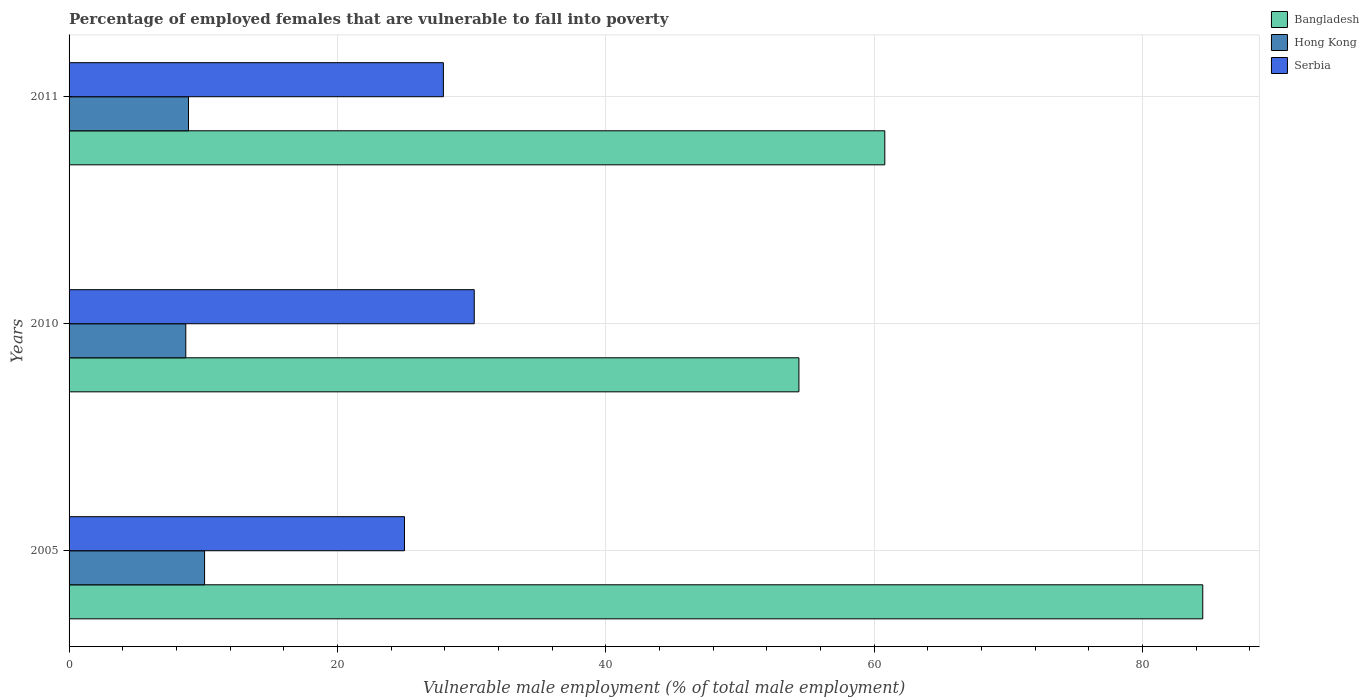How many groups of bars are there?
Ensure brevity in your answer.  3. Are the number of bars per tick equal to the number of legend labels?
Provide a short and direct response. Yes. Are the number of bars on each tick of the Y-axis equal?
Make the answer very short. Yes. How many bars are there on the 2nd tick from the bottom?
Your answer should be very brief. 3. What is the label of the 3rd group of bars from the top?
Your response must be concise. 2005. What is the percentage of employed females who are vulnerable to fall into poverty in Serbia in 2010?
Provide a succinct answer. 30.2. Across all years, what is the maximum percentage of employed females who are vulnerable to fall into poverty in Serbia?
Keep it short and to the point. 30.2. Across all years, what is the minimum percentage of employed females who are vulnerable to fall into poverty in Serbia?
Provide a succinct answer. 25. In which year was the percentage of employed females who are vulnerable to fall into poverty in Hong Kong minimum?
Your response must be concise. 2010. What is the total percentage of employed females who are vulnerable to fall into poverty in Bangladesh in the graph?
Your response must be concise. 199.7. What is the difference between the percentage of employed females who are vulnerable to fall into poverty in Bangladesh in 2005 and that in 2010?
Provide a succinct answer. 30.1. What is the difference between the percentage of employed females who are vulnerable to fall into poverty in Hong Kong in 2010 and the percentage of employed females who are vulnerable to fall into poverty in Serbia in 2005?
Give a very brief answer. -16.3. What is the average percentage of employed females who are vulnerable to fall into poverty in Serbia per year?
Keep it short and to the point. 27.7. In the year 2010, what is the difference between the percentage of employed females who are vulnerable to fall into poverty in Serbia and percentage of employed females who are vulnerable to fall into poverty in Bangladesh?
Give a very brief answer. -24.2. In how many years, is the percentage of employed females who are vulnerable to fall into poverty in Serbia greater than 24 %?
Give a very brief answer. 3. What is the ratio of the percentage of employed females who are vulnerable to fall into poverty in Serbia in 2005 to that in 2010?
Make the answer very short. 0.83. What is the difference between the highest and the second highest percentage of employed females who are vulnerable to fall into poverty in Bangladesh?
Your response must be concise. 23.7. What is the difference between the highest and the lowest percentage of employed females who are vulnerable to fall into poverty in Hong Kong?
Provide a short and direct response. 1.4. In how many years, is the percentage of employed females who are vulnerable to fall into poverty in Bangladesh greater than the average percentage of employed females who are vulnerable to fall into poverty in Bangladesh taken over all years?
Provide a short and direct response. 1. What does the 1st bar from the top in 2005 represents?
Provide a succinct answer. Serbia. What does the 2nd bar from the bottom in 2005 represents?
Give a very brief answer. Hong Kong. Is it the case that in every year, the sum of the percentage of employed females who are vulnerable to fall into poverty in Serbia and percentage of employed females who are vulnerable to fall into poverty in Hong Kong is greater than the percentage of employed females who are vulnerable to fall into poverty in Bangladesh?
Your answer should be compact. No. How many bars are there?
Your answer should be very brief. 9. What is the title of the graph?
Offer a terse response. Percentage of employed females that are vulnerable to fall into poverty. What is the label or title of the X-axis?
Your response must be concise. Vulnerable male employment (% of total male employment). What is the label or title of the Y-axis?
Your answer should be compact. Years. What is the Vulnerable male employment (% of total male employment) in Bangladesh in 2005?
Ensure brevity in your answer.  84.5. What is the Vulnerable male employment (% of total male employment) of Hong Kong in 2005?
Offer a terse response. 10.1. What is the Vulnerable male employment (% of total male employment) of Serbia in 2005?
Give a very brief answer. 25. What is the Vulnerable male employment (% of total male employment) in Bangladesh in 2010?
Your answer should be compact. 54.4. What is the Vulnerable male employment (% of total male employment) in Hong Kong in 2010?
Provide a short and direct response. 8.7. What is the Vulnerable male employment (% of total male employment) in Serbia in 2010?
Offer a very short reply. 30.2. What is the Vulnerable male employment (% of total male employment) of Bangladesh in 2011?
Ensure brevity in your answer.  60.8. What is the Vulnerable male employment (% of total male employment) in Hong Kong in 2011?
Keep it short and to the point. 8.9. What is the Vulnerable male employment (% of total male employment) in Serbia in 2011?
Your answer should be very brief. 27.9. Across all years, what is the maximum Vulnerable male employment (% of total male employment) in Bangladesh?
Ensure brevity in your answer.  84.5. Across all years, what is the maximum Vulnerable male employment (% of total male employment) of Hong Kong?
Make the answer very short. 10.1. Across all years, what is the maximum Vulnerable male employment (% of total male employment) in Serbia?
Provide a succinct answer. 30.2. Across all years, what is the minimum Vulnerable male employment (% of total male employment) of Bangladesh?
Ensure brevity in your answer.  54.4. Across all years, what is the minimum Vulnerable male employment (% of total male employment) in Hong Kong?
Provide a succinct answer. 8.7. What is the total Vulnerable male employment (% of total male employment) of Bangladesh in the graph?
Offer a terse response. 199.7. What is the total Vulnerable male employment (% of total male employment) of Hong Kong in the graph?
Provide a succinct answer. 27.7. What is the total Vulnerable male employment (% of total male employment) in Serbia in the graph?
Ensure brevity in your answer.  83.1. What is the difference between the Vulnerable male employment (% of total male employment) of Bangladesh in 2005 and that in 2010?
Offer a terse response. 30.1. What is the difference between the Vulnerable male employment (% of total male employment) of Bangladesh in 2005 and that in 2011?
Keep it short and to the point. 23.7. What is the difference between the Vulnerable male employment (% of total male employment) of Serbia in 2005 and that in 2011?
Ensure brevity in your answer.  -2.9. What is the difference between the Vulnerable male employment (% of total male employment) in Bangladesh in 2010 and that in 2011?
Keep it short and to the point. -6.4. What is the difference between the Vulnerable male employment (% of total male employment) in Bangladesh in 2005 and the Vulnerable male employment (% of total male employment) in Hong Kong in 2010?
Your response must be concise. 75.8. What is the difference between the Vulnerable male employment (% of total male employment) in Bangladesh in 2005 and the Vulnerable male employment (% of total male employment) in Serbia in 2010?
Your answer should be very brief. 54.3. What is the difference between the Vulnerable male employment (% of total male employment) of Hong Kong in 2005 and the Vulnerable male employment (% of total male employment) of Serbia in 2010?
Give a very brief answer. -20.1. What is the difference between the Vulnerable male employment (% of total male employment) in Bangladesh in 2005 and the Vulnerable male employment (% of total male employment) in Hong Kong in 2011?
Your response must be concise. 75.6. What is the difference between the Vulnerable male employment (% of total male employment) of Bangladesh in 2005 and the Vulnerable male employment (% of total male employment) of Serbia in 2011?
Make the answer very short. 56.6. What is the difference between the Vulnerable male employment (% of total male employment) in Hong Kong in 2005 and the Vulnerable male employment (% of total male employment) in Serbia in 2011?
Provide a short and direct response. -17.8. What is the difference between the Vulnerable male employment (% of total male employment) in Bangladesh in 2010 and the Vulnerable male employment (% of total male employment) in Hong Kong in 2011?
Ensure brevity in your answer.  45.5. What is the difference between the Vulnerable male employment (% of total male employment) of Bangladesh in 2010 and the Vulnerable male employment (% of total male employment) of Serbia in 2011?
Ensure brevity in your answer.  26.5. What is the difference between the Vulnerable male employment (% of total male employment) in Hong Kong in 2010 and the Vulnerable male employment (% of total male employment) in Serbia in 2011?
Keep it short and to the point. -19.2. What is the average Vulnerable male employment (% of total male employment) in Bangladesh per year?
Ensure brevity in your answer.  66.57. What is the average Vulnerable male employment (% of total male employment) of Hong Kong per year?
Make the answer very short. 9.23. What is the average Vulnerable male employment (% of total male employment) of Serbia per year?
Make the answer very short. 27.7. In the year 2005, what is the difference between the Vulnerable male employment (% of total male employment) in Bangladesh and Vulnerable male employment (% of total male employment) in Hong Kong?
Ensure brevity in your answer.  74.4. In the year 2005, what is the difference between the Vulnerable male employment (% of total male employment) in Bangladesh and Vulnerable male employment (% of total male employment) in Serbia?
Provide a short and direct response. 59.5. In the year 2005, what is the difference between the Vulnerable male employment (% of total male employment) of Hong Kong and Vulnerable male employment (% of total male employment) of Serbia?
Keep it short and to the point. -14.9. In the year 2010, what is the difference between the Vulnerable male employment (% of total male employment) of Bangladesh and Vulnerable male employment (% of total male employment) of Hong Kong?
Make the answer very short. 45.7. In the year 2010, what is the difference between the Vulnerable male employment (% of total male employment) of Bangladesh and Vulnerable male employment (% of total male employment) of Serbia?
Your answer should be compact. 24.2. In the year 2010, what is the difference between the Vulnerable male employment (% of total male employment) of Hong Kong and Vulnerable male employment (% of total male employment) of Serbia?
Offer a very short reply. -21.5. In the year 2011, what is the difference between the Vulnerable male employment (% of total male employment) of Bangladesh and Vulnerable male employment (% of total male employment) of Hong Kong?
Keep it short and to the point. 51.9. In the year 2011, what is the difference between the Vulnerable male employment (% of total male employment) of Bangladesh and Vulnerable male employment (% of total male employment) of Serbia?
Make the answer very short. 32.9. In the year 2011, what is the difference between the Vulnerable male employment (% of total male employment) in Hong Kong and Vulnerable male employment (% of total male employment) in Serbia?
Provide a short and direct response. -19. What is the ratio of the Vulnerable male employment (% of total male employment) of Bangladesh in 2005 to that in 2010?
Your answer should be compact. 1.55. What is the ratio of the Vulnerable male employment (% of total male employment) in Hong Kong in 2005 to that in 2010?
Provide a short and direct response. 1.16. What is the ratio of the Vulnerable male employment (% of total male employment) of Serbia in 2005 to that in 2010?
Provide a succinct answer. 0.83. What is the ratio of the Vulnerable male employment (% of total male employment) of Bangladesh in 2005 to that in 2011?
Provide a short and direct response. 1.39. What is the ratio of the Vulnerable male employment (% of total male employment) of Hong Kong in 2005 to that in 2011?
Offer a very short reply. 1.13. What is the ratio of the Vulnerable male employment (% of total male employment) of Serbia in 2005 to that in 2011?
Make the answer very short. 0.9. What is the ratio of the Vulnerable male employment (% of total male employment) in Bangladesh in 2010 to that in 2011?
Keep it short and to the point. 0.89. What is the ratio of the Vulnerable male employment (% of total male employment) of Hong Kong in 2010 to that in 2011?
Your answer should be compact. 0.98. What is the ratio of the Vulnerable male employment (% of total male employment) of Serbia in 2010 to that in 2011?
Give a very brief answer. 1.08. What is the difference between the highest and the second highest Vulnerable male employment (% of total male employment) in Bangladesh?
Your answer should be very brief. 23.7. What is the difference between the highest and the second highest Vulnerable male employment (% of total male employment) of Hong Kong?
Your answer should be very brief. 1.2. What is the difference between the highest and the lowest Vulnerable male employment (% of total male employment) of Bangladesh?
Your answer should be compact. 30.1. What is the difference between the highest and the lowest Vulnerable male employment (% of total male employment) in Hong Kong?
Provide a short and direct response. 1.4. 